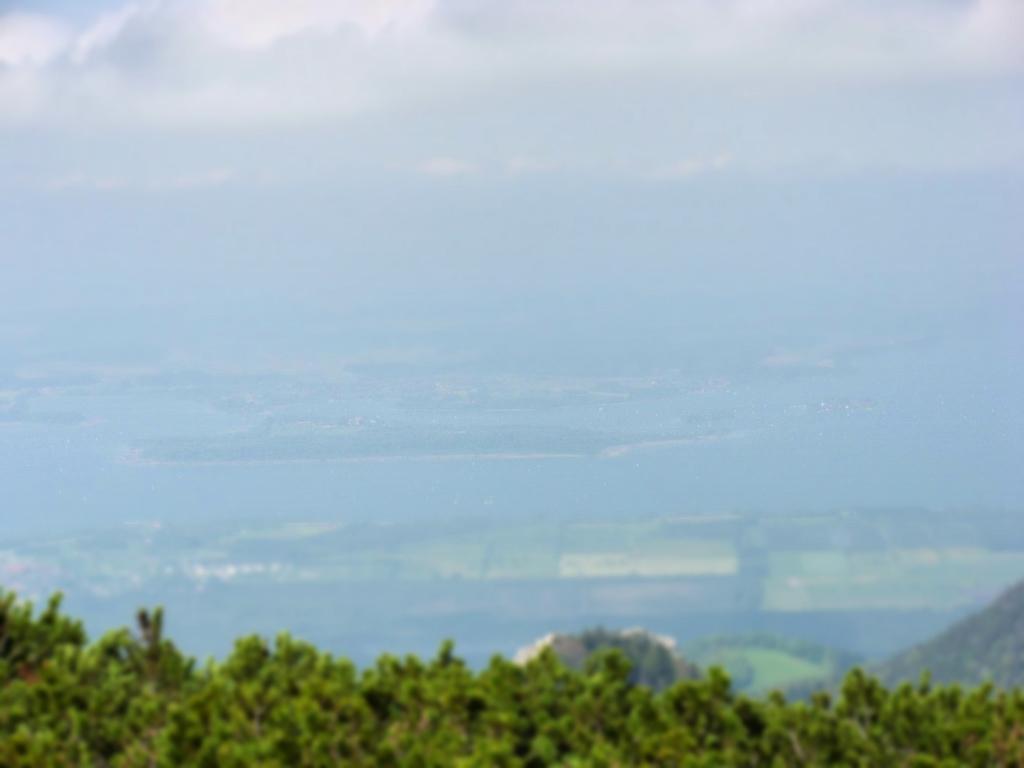Could you give a brief overview of what you see in this image? In this image we can see some plants at the bottom of the image and we can see the aerial view and the image is blurred in the background. 